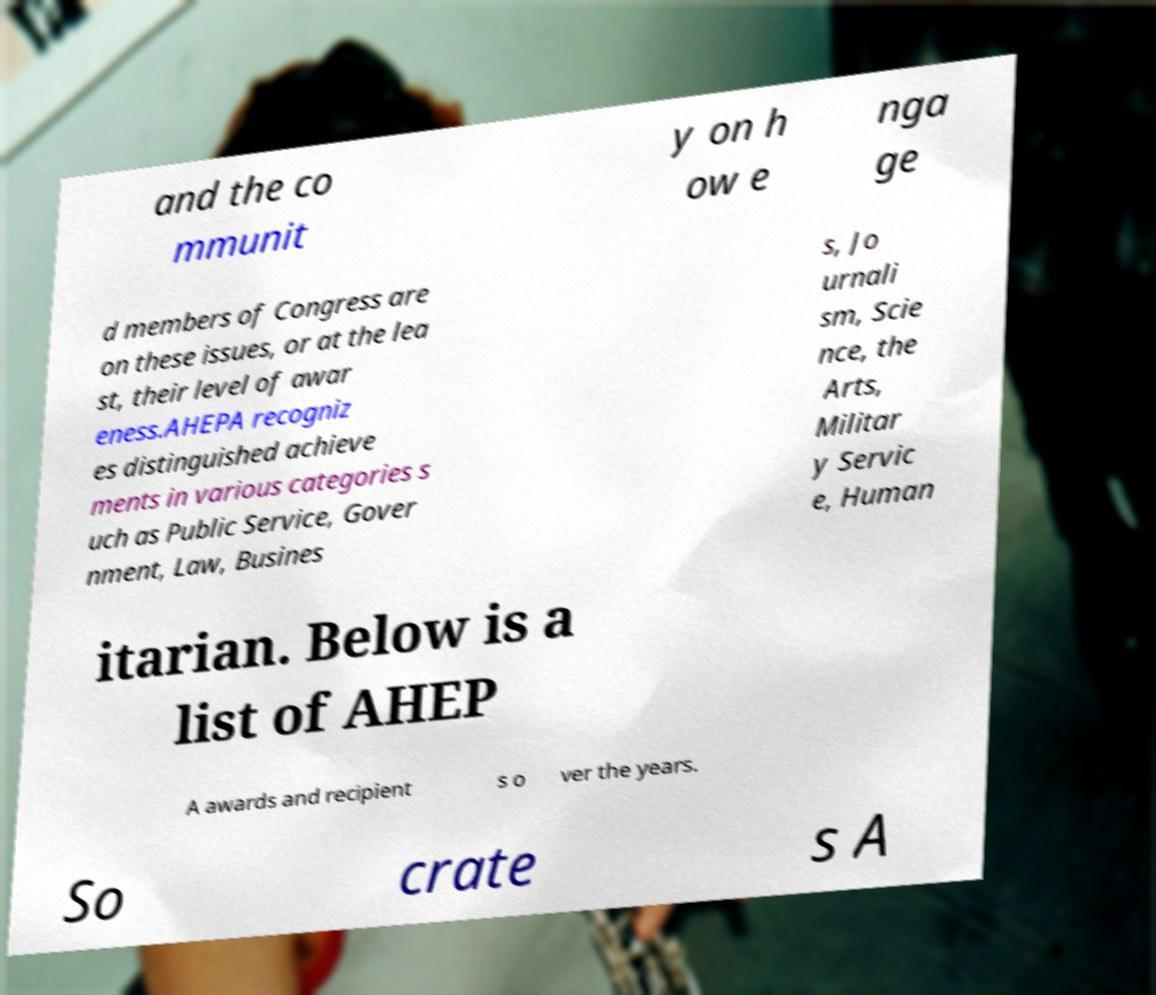There's text embedded in this image that I need extracted. Can you transcribe it verbatim? and the co mmunit y on h ow e nga ge d members of Congress are on these issues, or at the lea st, their level of awar eness.AHEPA recogniz es distinguished achieve ments in various categories s uch as Public Service, Gover nment, Law, Busines s, Jo urnali sm, Scie nce, the Arts, Militar y Servic e, Human itarian. Below is a list of AHEP A awards and recipient s o ver the years. So crate s A 